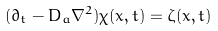Convert formula to latex. <formula><loc_0><loc_0><loc_500><loc_500>( \partial _ { t } - D _ { a } \nabla ^ { 2 } ) \chi ( { x } , t ) = \zeta ( { x } , t )</formula> 